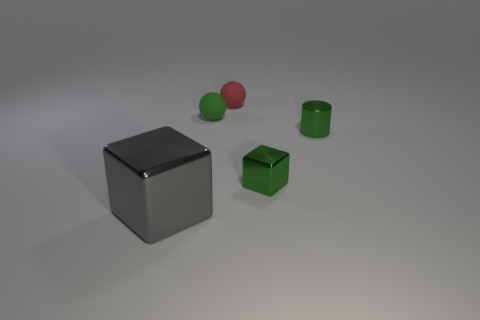Are there any other things that are the same size as the gray thing?
Offer a very short reply. No. What is the color of the other small sphere that is the same material as the red ball?
Provide a succinct answer. Green. How many metal objects are green objects or small blocks?
Your response must be concise. 2. Is the big gray object made of the same material as the small cylinder?
Give a very brief answer. Yes. What shape is the shiny object on the left side of the red sphere?
Provide a succinct answer. Cube. There is a block to the right of the gray metal cube; are there any small balls in front of it?
Provide a short and direct response. No. Are there any other green cylinders of the same size as the cylinder?
Give a very brief answer. No. There is a small shiny object that is to the left of the green cylinder; does it have the same color as the cylinder?
Make the answer very short. Yes. What is the size of the gray thing?
Offer a terse response. Large. What size is the metal cube that is on the left side of the tiny green thing that is left of the tiny metal block?
Make the answer very short. Large. 